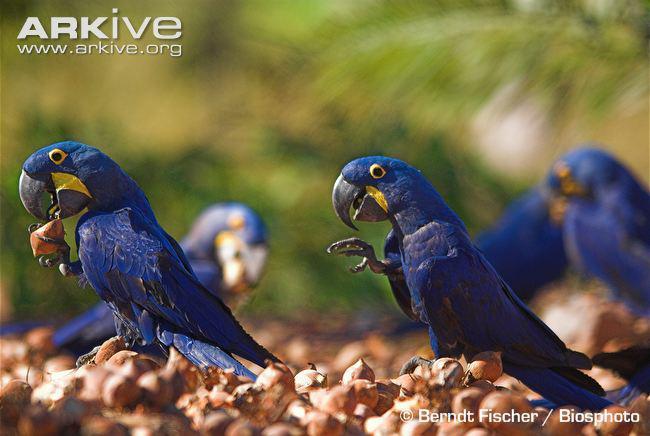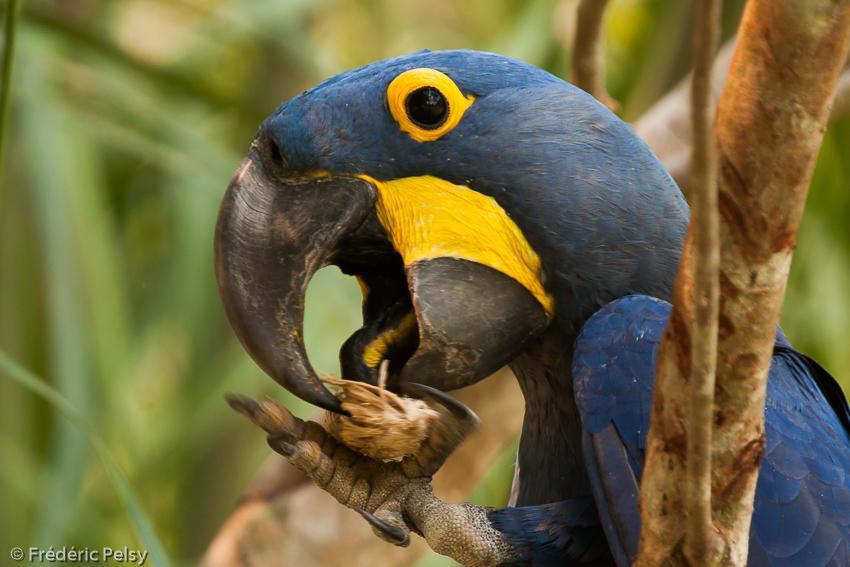The first image is the image on the left, the second image is the image on the right. For the images shown, is this caption "The right image contains no more than one blue parrot that is facing towards the left." true? Answer yes or no. Yes. 